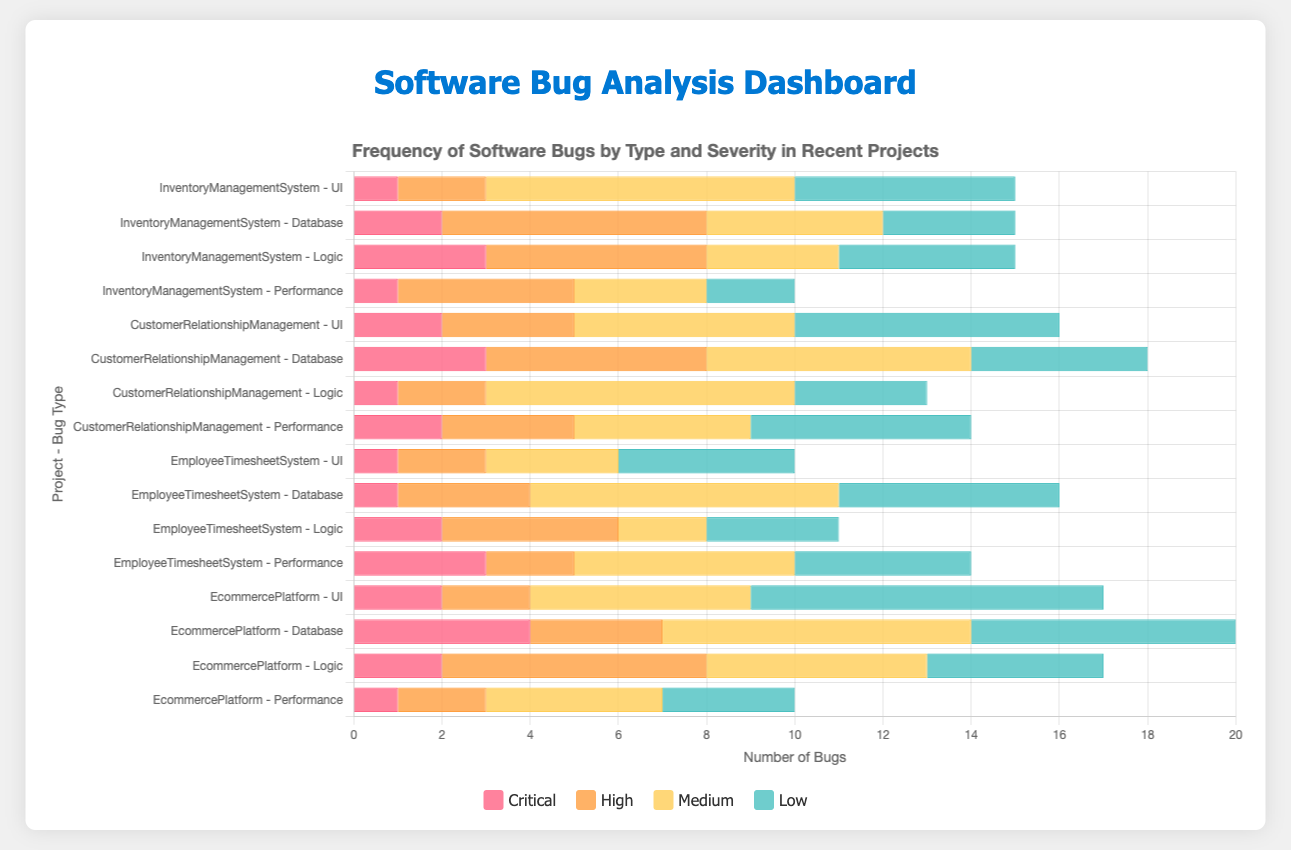What is the total number of critical bugs in the Inventory Management System? To find the total number of critical bugs in the Inventory Management System, sum the critical bugs for each bug type. UI has 1, Database has 2, Logic has 3, and Performance has 1. So, 1 + 2 + 3 + 1 = 7
Answer: 7 Which project has the highest number of medium severity UI bugs? Look at the horizontal bars for medium severity UI bugs across all projects. The Inventory Management System has 7, CustomerRelationshipManagement has 5, EmployeeTimesheetSystem has 3, and EcommercePlatform has 5. The highest number is 7 in the Inventory Management System.
Answer: Inventory Management System Comparing the UI bugs in all projects, which project has the least number of high severity UI bugs? Compare the lengths of the bars for high-severity UI bugs. InventoryManagementSystem has 2, CustomerRelationshipManagement has 3, EmployeeTimesheetSystem has 2, and EcommercePlatform has 2. All have the same number except for the Customer Relationship Management project, which has the highest.
Answer: Tie among InventoryManagementSystem, EmployeeTimesheetSystem, and EcommercePlatform How many more low severity bugs does the EcommercePlatform project have compared to the EmployeeTimesheetSystem project? Sum the low severity bugs for all types in both projects. EcommercePlatform has 8 (UI) + 6 (Database) + 4 (Logic) + 3 (Performance) = 21. EmployeeTimesheetSystem has 4 (UI) + 5 (Database) + 3 (Logic) + 4 (Performance) = 16. The difference is 21 - 16 = 5.
Answer: 5 What is the average number of medium severity bugs per bug type in the Customer Relationship Management project? Sum the medium severity bugs for each bug type in the Customer Relationship Management project and divide by the number of bug types. Medium severity: 5 (UI) + 6 (Database) + 7 (Logic) + 4 (Performance) = 22. There are 4 bug types. So, 22 / 4 = 5.5.
Answer: 5.5 Which project has the highest combined number of high severity bugs across all bug types? Sum the high severity bugs for each project. InventoryManagementSystem: 2 (UI) + 6 (Database) + 5 (Logic) + 4 (Performance) = 17. CustomerRelationshipManagement: 3 (UI) + 5 (Database) + 2 (Logic) + 3 (Performance) = 13. EmployeeTimesheetSystem: 2 (UI) + 3 (Database) + 4 (Logic) + 2 (Performance) = 11. EcommercePlatform: 2 (UI) + 3 (Database) + 6 (Logic) + 2 (Performance) = 13. The highest is 17 in the Inventory Management System.
Answer: Inventory Management System How many logical operations do you need to compute the total number of bugs in the EmployeeTimesheetSystem project? First, sum the bugs within each severity level and then add them together. UI: 4 (Low) + 3 (Medium) + 2 (High) + 1 (Critical) = 10, Database: 5 + 7 + 3 + 1 = 16, Logic: 3 + 2 + 4 + 2 = 11, Performance: 4 + 5 + 2 + 3 = 14. Then add these sums: 10 + 16 + 11 + 14 = 51. Total of 3 sums and 1 final addition operation: 4 operations.
Answer: 4 What is the total number of low severity bugs across all projects and bug types? Sum all the low severity bugs for each project. InventoryManagementSystem: 5 (UI) + 3 (Database) + 4 (Logic) + 2 (Performance) = 14. CustomerRelationshipManagement: 6 + 4 + 3 + 5 = 18. EmployeeTimesheetSystem: 4 + 5 + 3 + 4 = 16. EcommercePlatform: 8 + 6 + 4 + 3 = 21. Then add these sums: 14 + 18 + 16 + 21 = 69.
Answer: 69 